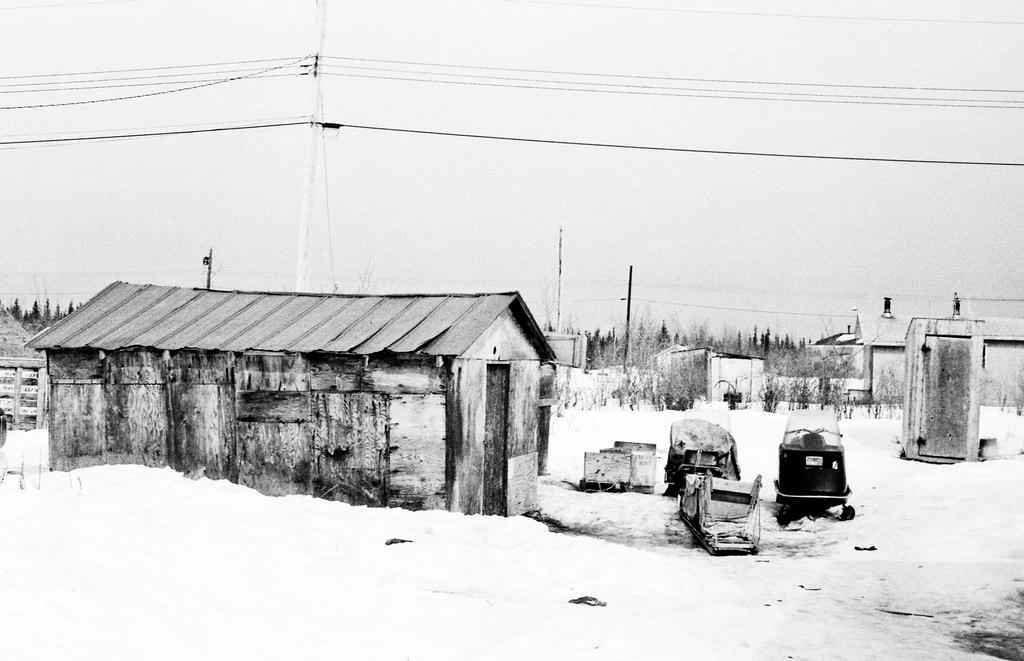What type of structure is visible in the image? There is a house in the image. What other natural elements can be seen in the image? There are trees in the image. Are there any man-made structures or objects besides the house? Yes, there are poles with cables in the image. What is visible in the background of the image? The sky is visible in the image. Can you see any dinosaurs roaming around in the image? No, there are no dinosaurs present in the image. What type of thrill can be experienced by the parent in the image? There is no parent or any indication of a thrilling experience in the image. 